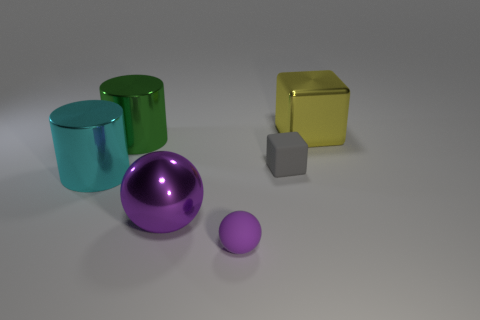Add 3 big metallic cubes. How many objects exist? 9 Subtract all blocks. How many objects are left? 4 Subtract 1 yellow cubes. How many objects are left? 5 Subtract all small brown metallic things. Subtract all large cylinders. How many objects are left? 4 Add 5 big purple objects. How many big purple objects are left? 6 Add 3 cylinders. How many cylinders exist? 5 